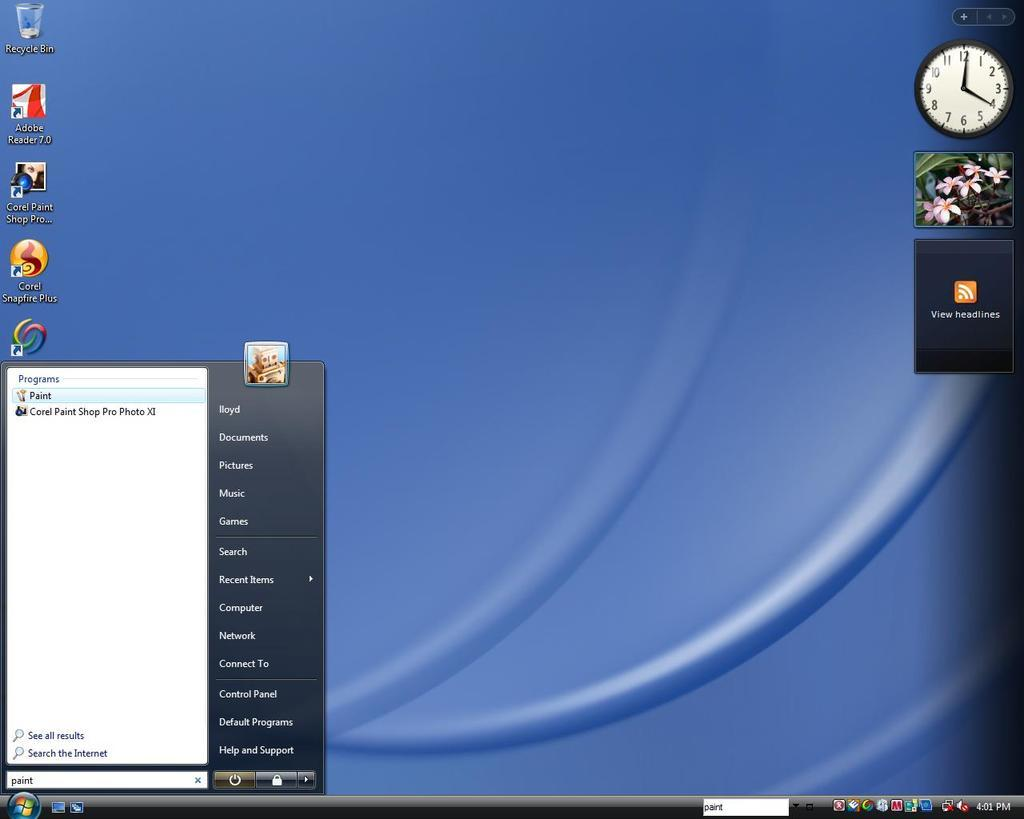<image>
Relay a brief, clear account of the picture shown. A Windows desktop screen with a blue background. 